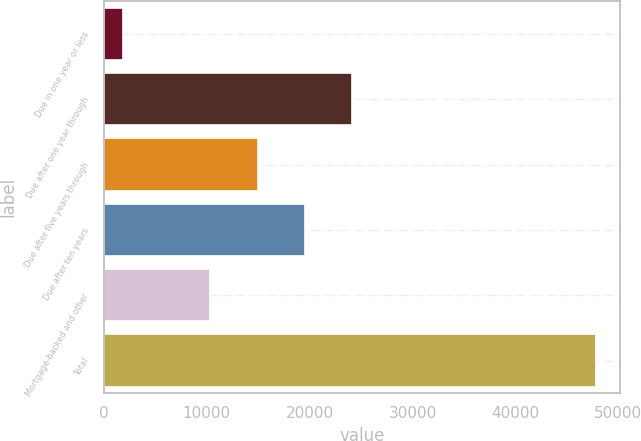<chart> <loc_0><loc_0><loc_500><loc_500><bar_chart><fcel>Due in one year or less<fcel>Due after one year through<fcel>Due after five years through<fcel>Due after ten years<fcel>Mortgage-backed and other<fcel>Total<nl><fcel>1854.7<fcel>24137.3<fcel>14943.2<fcel>19540.2<fcel>10346.1<fcel>47825.3<nl></chart> 